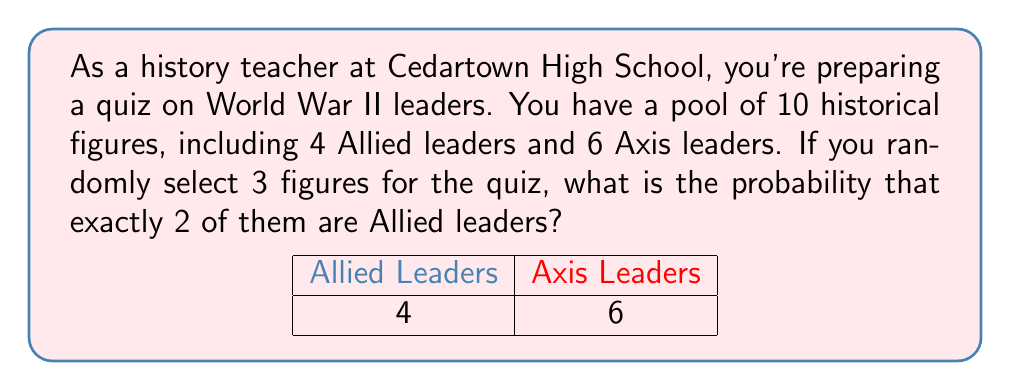What is the answer to this math problem? Let's approach this step-by-step using the concept of combinatorics:

1) First, we need to calculate the total number of ways to select 3 figures out of 10. This is given by the combination formula:

   $$\binom{10}{3} = \frac{10!}{3!(10-3)!} = \frac{10!}{3!7!} = 120$$

2) Now, we need to calculate the number of ways to select exactly 2 Allied leaders and 1 Axis leader:

   a) Select 2 Allied leaders out of 4: $$\binom{4}{2} = \frac{4!}{2!2!} = 6$$
   
   b) Select 1 Axis leader out of 6: $$\binom{6}{1} = 6$$

3) By the multiplication principle, the total number of favorable outcomes is:

   $$6 * 6 = 36$$

4) The probability is then the number of favorable outcomes divided by the total number of possible outcomes:

   $$P(\text{exactly 2 Allied leaders}) = \frac{36}{120} = \frac{3}{10} = 0.3$$
Answer: $\frac{3}{10}$ or $0.3$ or $30\%$ 